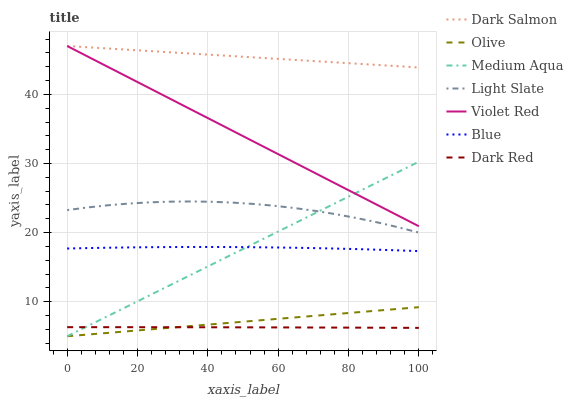Does Dark Red have the minimum area under the curve?
Answer yes or no. Yes. Does Dark Salmon have the maximum area under the curve?
Answer yes or no. Yes. Does Violet Red have the minimum area under the curve?
Answer yes or no. No. Does Violet Red have the maximum area under the curve?
Answer yes or no. No. Is Olive the smoothest?
Answer yes or no. Yes. Is Light Slate the roughest?
Answer yes or no. Yes. Is Violet Red the smoothest?
Answer yes or no. No. Is Violet Red the roughest?
Answer yes or no. No. Does Medium Aqua have the lowest value?
Answer yes or no. Yes. Does Violet Red have the lowest value?
Answer yes or no. No. Does Dark Salmon have the highest value?
Answer yes or no. Yes. Does Light Slate have the highest value?
Answer yes or no. No. Is Light Slate less than Dark Salmon?
Answer yes or no. Yes. Is Violet Red greater than Blue?
Answer yes or no. Yes. Does Dark Salmon intersect Violet Red?
Answer yes or no. Yes. Is Dark Salmon less than Violet Red?
Answer yes or no. No. Is Dark Salmon greater than Violet Red?
Answer yes or no. No. Does Light Slate intersect Dark Salmon?
Answer yes or no. No. 